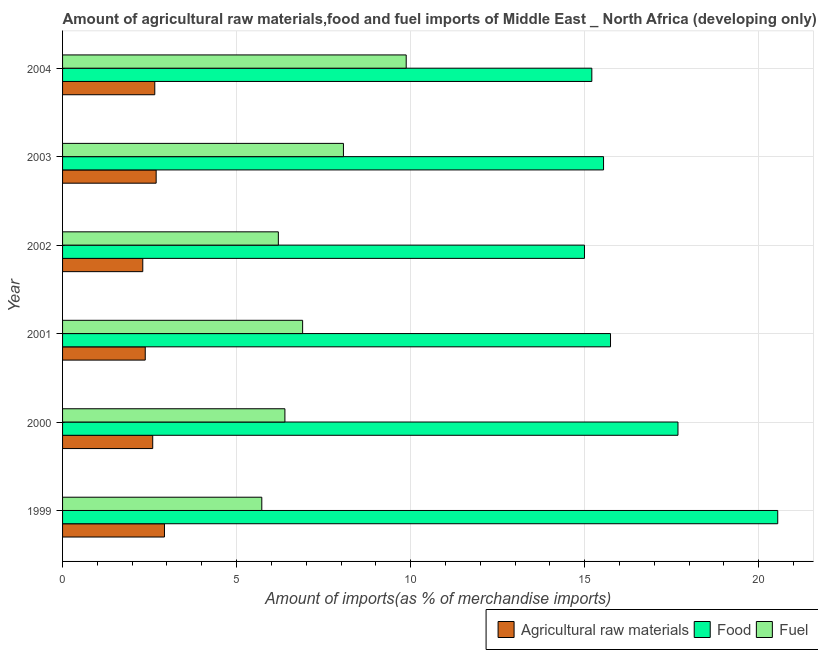How many bars are there on the 5th tick from the top?
Your answer should be very brief. 3. What is the label of the 4th group of bars from the top?
Provide a succinct answer. 2001. What is the percentage of fuel imports in 2000?
Your answer should be compact. 6.39. Across all years, what is the maximum percentage of fuel imports?
Provide a short and direct response. 9.87. Across all years, what is the minimum percentage of fuel imports?
Provide a succinct answer. 5.72. What is the total percentage of raw materials imports in the graph?
Ensure brevity in your answer.  15.54. What is the difference between the percentage of fuel imports in 1999 and that in 2003?
Keep it short and to the point. -2.35. What is the difference between the percentage of food imports in 1999 and the percentage of fuel imports in 2004?
Keep it short and to the point. 10.67. What is the average percentage of food imports per year?
Make the answer very short. 16.62. In the year 2000, what is the difference between the percentage of food imports and percentage of fuel imports?
Your response must be concise. 11.29. What is the difference between the highest and the second highest percentage of fuel imports?
Ensure brevity in your answer.  1.8. What is the difference between the highest and the lowest percentage of fuel imports?
Your answer should be very brief. 4.15. In how many years, is the percentage of raw materials imports greater than the average percentage of raw materials imports taken over all years?
Make the answer very short. 4. What does the 1st bar from the top in 2004 represents?
Make the answer very short. Fuel. What does the 1st bar from the bottom in 1999 represents?
Ensure brevity in your answer.  Agricultural raw materials. Is it the case that in every year, the sum of the percentage of raw materials imports and percentage of food imports is greater than the percentage of fuel imports?
Make the answer very short. Yes. How many bars are there?
Offer a very short reply. 18. Are all the bars in the graph horizontal?
Your answer should be compact. Yes. How many years are there in the graph?
Keep it short and to the point. 6. What is the difference between two consecutive major ticks on the X-axis?
Make the answer very short. 5. Does the graph contain grids?
Your answer should be compact. Yes. What is the title of the graph?
Offer a terse response. Amount of agricultural raw materials,food and fuel imports of Middle East _ North Africa (developing only). What is the label or title of the X-axis?
Make the answer very short. Amount of imports(as % of merchandise imports). What is the label or title of the Y-axis?
Your answer should be compact. Year. What is the Amount of imports(as % of merchandise imports) of Agricultural raw materials in 1999?
Your answer should be very brief. 2.93. What is the Amount of imports(as % of merchandise imports) in Food in 1999?
Provide a succinct answer. 20.55. What is the Amount of imports(as % of merchandise imports) of Fuel in 1999?
Your answer should be very brief. 5.72. What is the Amount of imports(as % of merchandise imports) of Agricultural raw materials in 2000?
Ensure brevity in your answer.  2.59. What is the Amount of imports(as % of merchandise imports) in Food in 2000?
Offer a terse response. 17.68. What is the Amount of imports(as % of merchandise imports) of Fuel in 2000?
Offer a terse response. 6.39. What is the Amount of imports(as % of merchandise imports) in Agricultural raw materials in 2001?
Offer a terse response. 2.38. What is the Amount of imports(as % of merchandise imports) in Food in 2001?
Make the answer very short. 15.74. What is the Amount of imports(as % of merchandise imports) in Fuel in 2001?
Offer a terse response. 6.9. What is the Amount of imports(as % of merchandise imports) of Agricultural raw materials in 2002?
Give a very brief answer. 2.3. What is the Amount of imports(as % of merchandise imports) of Food in 2002?
Give a very brief answer. 14.99. What is the Amount of imports(as % of merchandise imports) in Fuel in 2002?
Your answer should be compact. 6.2. What is the Amount of imports(as % of merchandise imports) in Agricultural raw materials in 2003?
Keep it short and to the point. 2.69. What is the Amount of imports(as % of merchandise imports) of Food in 2003?
Give a very brief answer. 15.54. What is the Amount of imports(as % of merchandise imports) of Fuel in 2003?
Make the answer very short. 8.07. What is the Amount of imports(as % of merchandise imports) in Agricultural raw materials in 2004?
Keep it short and to the point. 2.65. What is the Amount of imports(as % of merchandise imports) of Food in 2004?
Your answer should be very brief. 15.2. What is the Amount of imports(as % of merchandise imports) in Fuel in 2004?
Ensure brevity in your answer.  9.87. Across all years, what is the maximum Amount of imports(as % of merchandise imports) in Agricultural raw materials?
Your response must be concise. 2.93. Across all years, what is the maximum Amount of imports(as % of merchandise imports) of Food?
Give a very brief answer. 20.55. Across all years, what is the maximum Amount of imports(as % of merchandise imports) of Fuel?
Your answer should be very brief. 9.87. Across all years, what is the minimum Amount of imports(as % of merchandise imports) of Agricultural raw materials?
Provide a short and direct response. 2.3. Across all years, what is the minimum Amount of imports(as % of merchandise imports) in Food?
Provide a succinct answer. 14.99. Across all years, what is the minimum Amount of imports(as % of merchandise imports) of Fuel?
Give a very brief answer. 5.72. What is the total Amount of imports(as % of merchandise imports) in Agricultural raw materials in the graph?
Provide a short and direct response. 15.54. What is the total Amount of imports(as % of merchandise imports) in Food in the graph?
Your response must be concise. 99.71. What is the total Amount of imports(as % of merchandise imports) in Fuel in the graph?
Make the answer very short. 43.15. What is the difference between the Amount of imports(as % of merchandise imports) in Agricultural raw materials in 1999 and that in 2000?
Your answer should be compact. 0.34. What is the difference between the Amount of imports(as % of merchandise imports) in Food in 1999 and that in 2000?
Your answer should be compact. 2.87. What is the difference between the Amount of imports(as % of merchandise imports) in Fuel in 1999 and that in 2000?
Your response must be concise. -0.66. What is the difference between the Amount of imports(as % of merchandise imports) of Agricultural raw materials in 1999 and that in 2001?
Your answer should be compact. 0.55. What is the difference between the Amount of imports(as % of merchandise imports) in Food in 1999 and that in 2001?
Make the answer very short. 4.8. What is the difference between the Amount of imports(as % of merchandise imports) in Fuel in 1999 and that in 2001?
Give a very brief answer. -1.17. What is the difference between the Amount of imports(as % of merchandise imports) of Agricultural raw materials in 1999 and that in 2002?
Provide a succinct answer. 0.62. What is the difference between the Amount of imports(as % of merchandise imports) of Food in 1999 and that in 2002?
Make the answer very short. 5.55. What is the difference between the Amount of imports(as % of merchandise imports) in Fuel in 1999 and that in 2002?
Provide a succinct answer. -0.48. What is the difference between the Amount of imports(as % of merchandise imports) of Agricultural raw materials in 1999 and that in 2003?
Provide a succinct answer. 0.24. What is the difference between the Amount of imports(as % of merchandise imports) of Food in 1999 and that in 2003?
Your answer should be very brief. 5. What is the difference between the Amount of imports(as % of merchandise imports) in Fuel in 1999 and that in 2003?
Your answer should be compact. -2.35. What is the difference between the Amount of imports(as % of merchandise imports) of Agricultural raw materials in 1999 and that in 2004?
Provide a succinct answer. 0.28. What is the difference between the Amount of imports(as % of merchandise imports) in Food in 1999 and that in 2004?
Your answer should be compact. 5.34. What is the difference between the Amount of imports(as % of merchandise imports) in Fuel in 1999 and that in 2004?
Your response must be concise. -4.15. What is the difference between the Amount of imports(as % of merchandise imports) of Agricultural raw materials in 2000 and that in 2001?
Provide a short and direct response. 0.21. What is the difference between the Amount of imports(as % of merchandise imports) of Food in 2000 and that in 2001?
Ensure brevity in your answer.  1.94. What is the difference between the Amount of imports(as % of merchandise imports) of Fuel in 2000 and that in 2001?
Offer a very short reply. -0.51. What is the difference between the Amount of imports(as % of merchandise imports) of Agricultural raw materials in 2000 and that in 2002?
Offer a terse response. 0.29. What is the difference between the Amount of imports(as % of merchandise imports) in Food in 2000 and that in 2002?
Give a very brief answer. 2.69. What is the difference between the Amount of imports(as % of merchandise imports) of Fuel in 2000 and that in 2002?
Your answer should be compact. 0.19. What is the difference between the Amount of imports(as % of merchandise imports) in Agricultural raw materials in 2000 and that in 2003?
Make the answer very short. -0.1. What is the difference between the Amount of imports(as % of merchandise imports) in Food in 2000 and that in 2003?
Keep it short and to the point. 2.14. What is the difference between the Amount of imports(as % of merchandise imports) of Fuel in 2000 and that in 2003?
Provide a short and direct response. -1.68. What is the difference between the Amount of imports(as % of merchandise imports) of Agricultural raw materials in 2000 and that in 2004?
Provide a short and direct response. -0.06. What is the difference between the Amount of imports(as % of merchandise imports) of Food in 2000 and that in 2004?
Provide a succinct answer. 2.47. What is the difference between the Amount of imports(as % of merchandise imports) of Fuel in 2000 and that in 2004?
Your answer should be very brief. -3.48. What is the difference between the Amount of imports(as % of merchandise imports) of Agricultural raw materials in 2001 and that in 2002?
Provide a short and direct response. 0.07. What is the difference between the Amount of imports(as % of merchandise imports) in Food in 2001 and that in 2002?
Give a very brief answer. 0.75. What is the difference between the Amount of imports(as % of merchandise imports) in Fuel in 2001 and that in 2002?
Ensure brevity in your answer.  0.7. What is the difference between the Amount of imports(as % of merchandise imports) of Agricultural raw materials in 2001 and that in 2003?
Ensure brevity in your answer.  -0.31. What is the difference between the Amount of imports(as % of merchandise imports) of Food in 2001 and that in 2003?
Offer a terse response. 0.2. What is the difference between the Amount of imports(as % of merchandise imports) in Fuel in 2001 and that in 2003?
Make the answer very short. -1.17. What is the difference between the Amount of imports(as % of merchandise imports) in Agricultural raw materials in 2001 and that in 2004?
Offer a very short reply. -0.27. What is the difference between the Amount of imports(as % of merchandise imports) in Food in 2001 and that in 2004?
Provide a short and direct response. 0.54. What is the difference between the Amount of imports(as % of merchandise imports) in Fuel in 2001 and that in 2004?
Keep it short and to the point. -2.98. What is the difference between the Amount of imports(as % of merchandise imports) of Agricultural raw materials in 2002 and that in 2003?
Your answer should be compact. -0.38. What is the difference between the Amount of imports(as % of merchandise imports) of Food in 2002 and that in 2003?
Keep it short and to the point. -0.55. What is the difference between the Amount of imports(as % of merchandise imports) of Fuel in 2002 and that in 2003?
Provide a short and direct response. -1.87. What is the difference between the Amount of imports(as % of merchandise imports) of Agricultural raw materials in 2002 and that in 2004?
Offer a terse response. -0.34. What is the difference between the Amount of imports(as % of merchandise imports) in Food in 2002 and that in 2004?
Make the answer very short. -0.21. What is the difference between the Amount of imports(as % of merchandise imports) in Fuel in 2002 and that in 2004?
Your answer should be compact. -3.67. What is the difference between the Amount of imports(as % of merchandise imports) in Agricultural raw materials in 2003 and that in 2004?
Offer a terse response. 0.04. What is the difference between the Amount of imports(as % of merchandise imports) in Food in 2003 and that in 2004?
Give a very brief answer. 0.34. What is the difference between the Amount of imports(as % of merchandise imports) of Fuel in 2003 and that in 2004?
Provide a succinct answer. -1.8. What is the difference between the Amount of imports(as % of merchandise imports) of Agricultural raw materials in 1999 and the Amount of imports(as % of merchandise imports) of Food in 2000?
Provide a short and direct response. -14.75. What is the difference between the Amount of imports(as % of merchandise imports) in Agricultural raw materials in 1999 and the Amount of imports(as % of merchandise imports) in Fuel in 2000?
Keep it short and to the point. -3.46. What is the difference between the Amount of imports(as % of merchandise imports) of Food in 1999 and the Amount of imports(as % of merchandise imports) of Fuel in 2000?
Your answer should be compact. 14.16. What is the difference between the Amount of imports(as % of merchandise imports) in Agricultural raw materials in 1999 and the Amount of imports(as % of merchandise imports) in Food in 2001?
Ensure brevity in your answer.  -12.81. What is the difference between the Amount of imports(as % of merchandise imports) of Agricultural raw materials in 1999 and the Amount of imports(as % of merchandise imports) of Fuel in 2001?
Your answer should be compact. -3.97. What is the difference between the Amount of imports(as % of merchandise imports) of Food in 1999 and the Amount of imports(as % of merchandise imports) of Fuel in 2001?
Give a very brief answer. 13.65. What is the difference between the Amount of imports(as % of merchandise imports) in Agricultural raw materials in 1999 and the Amount of imports(as % of merchandise imports) in Food in 2002?
Offer a very short reply. -12.07. What is the difference between the Amount of imports(as % of merchandise imports) of Agricultural raw materials in 1999 and the Amount of imports(as % of merchandise imports) of Fuel in 2002?
Give a very brief answer. -3.27. What is the difference between the Amount of imports(as % of merchandise imports) of Food in 1999 and the Amount of imports(as % of merchandise imports) of Fuel in 2002?
Provide a succinct answer. 14.35. What is the difference between the Amount of imports(as % of merchandise imports) of Agricultural raw materials in 1999 and the Amount of imports(as % of merchandise imports) of Food in 2003?
Keep it short and to the point. -12.61. What is the difference between the Amount of imports(as % of merchandise imports) of Agricultural raw materials in 1999 and the Amount of imports(as % of merchandise imports) of Fuel in 2003?
Your response must be concise. -5.14. What is the difference between the Amount of imports(as % of merchandise imports) of Food in 1999 and the Amount of imports(as % of merchandise imports) of Fuel in 2003?
Provide a succinct answer. 12.48. What is the difference between the Amount of imports(as % of merchandise imports) in Agricultural raw materials in 1999 and the Amount of imports(as % of merchandise imports) in Food in 2004?
Make the answer very short. -12.28. What is the difference between the Amount of imports(as % of merchandise imports) in Agricultural raw materials in 1999 and the Amount of imports(as % of merchandise imports) in Fuel in 2004?
Keep it short and to the point. -6.94. What is the difference between the Amount of imports(as % of merchandise imports) of Food in 1999 and the Amount of imports(as % of merchandise imports) of Fuel in 2004?
Ensure brevity in your answer.  10.67. What is the difference between the Amount of imports(as % of merchandise imports) in Agricultural raw materials in 2000 and the Amount of imports(as % of merchandise imports) in Food in 2001?
Offer a terse response. -13.15. What is the difference between the Amount of imports(as % of merchandise imports) in Agricultural raw materials in 2000 and the Amount of imports(as % of merchandise imports) in Fuel in 2001?
Provide a short and direct response. -4.31. What is the difference between the Amount of imports(as % of merchandise imports) of Food in 2000 and the Amount of imports(as % of merchandise imports) of Fuel in 2001?
Offer a terse response. 10.78. What is the difference between the Amount of imports(as % of merchandise imports) in Agricultural raw materials in 2000 and the Amount of imports(as % of merchandise imports) in Food in 2002?
Provide a short and direct response. -12.4. What is the difference between the Amount of imports(as % of merchandise imports) in Agricultural raw materials in 2000 and the Amount of imports(as % of merchandise imports) in Fuel in 2002?
Your answer should be very brief. -3.61. What is the difference between the Amount of imports(as % of merchandise imports) in Food in 2000 and the Amount of imports(as % of merchandise imports) in Fuel in 2002?
Ensure brevity in your answer.  11.48. What is the difference between the Amount of imports(as % of merchandise imports) in Agricultural raw materials in 2000 and the Amount of imports(as % of merchandise imports) in Food in 2003?
Ensure brevity in your answer.  -12.95. What is the difference between the Amount of imports(as % of merchandise imports) in Agricultural raw materials in 2000 and the Amount of imports(as % of merchandise imports) in Fuel in 2003?
Give a very brief answer. -5.48. What is the difference between the Amount of imports(as % of merchandise imports) of Food in 2000 and the Amount of imports(as % of merchandise imports) of Fuel in 2003?
Your answer should be compact. 9.61. What is the difference between the Amount of imports(as % of merchandise imports) of Agricultural raw materials in 2000 and the Amount of imports(as % of merchandise imports) of Food in 2004?
Provide a short and direct response. -12.62. What is the difference between the Amount of imports(as % of merchandise imports) in Agricultural raw materials in 2000 and the Amount of imports(as % of merchandise imports) in Fuel in 2004?
Your answer should be compact. -7.28. What is the difference between the Amount of imports(as % of merchandise imports) in Food in 2000 and the Amount of imports(as % of merchandise imports) in Fuel in 2004?
Offer a terse response. 7.81. What is the difference between the Amount of imports(as % of merchandise imports) in Agricultural raw materials in 2001 and the Amount of imports(as % of merchandise imports) in Food in 2002?
Keep it short and to the point. -12.62. What is the difference between the Amount of imports(as % of merchandise imports) in Agricultural raw materials in 2001 and the Amount of imports(as % of merchandise imports) in Fuel in 2002?
Offer a terse response. -3.82. What is the difference between the Amount of imports(as % of merchandise imports) of Food in 2001 and the Amount of imports(as % of merchandise imports) of Fuel in 2002?
Your answer should be very brief. 9.54. What is the difference between the Amount of imports(as % of merchandise imports) in Agricultural raw materials in 2001 and the Amount of imports(as % of merchandise imports) in Food in 2003?
Your answer should be compact. -13.17. What is the difference between the Amount of imports(as % of merchandise imports) in Agricultural raw materials in 2001 and the Amount of imports(as % of merchandise imports) in Fuel in 2003?
Your response must be concise. -5.69. What is the difference between the Amount of imports(as % of merchandise imports) of Food in 2001 and the Amount of imports(as % of merchandise imports) of Fuel in 2003?
Give a very brief answer. 7.67. What is the difference between the Amount of imports(as % of merchandise imports) of Agricultural raw materials in 2001 and the Amount of imports(as % of merchandise imports) of Food in 2004?
Make the answer very short. -12.83. What is the difference between the Amount of imports(as % of merchandise imports) in Agricultural raw materials in 2001 and the Amount of imports(as % of merchandise imports) in Fuel in 2004?
Make the answer very short. -7.5. What is the difference between the Amount of imports(as % of merchandise imports) of Food in 2001 and the Amount of imports(as % of merchandise imports) of Fuel in 2004?
Your answer should be very brief. 5.87. What is the difference between the Amount of imports(as % of merchandise imports) of Agricultural raw materials in 2002 and the Amount of imports(as % of merchandise imports) of Food in 2003?
Make the answer very short. -13.24. What is the difference between the Amount of imports(as % of merchandise imports) of Agricultural raw materials in 2002 and the Amount of imports(as % of merchandise imports) of Fuel in 2003?
Your answer should be very brief. -5.76. What is the difference between the Amount of imports(as % of merchandise imports) in Food in 2002 and the Amount of imports(as % of merchandise imports) in Fuel in 2003?
Ensure brevity in your answer.  6.92. What is the difference between the Amount of imports(as % of merchandise imports) in Agricultural raw materials in 2002 and the Amount of imports(as % of merchandise imports) in Food in 2004?
Your answer should be very brief. -12.9. What is the difference between the Amount of imports(as % of merchandise imports) of Agricultural raw materials in 2002 and the Amount of imports(as % of merchandise imports) of Fuel in 2004?
Keep it short and to the point. -7.57. What is the difference between the Amount of imports(as % of merchandise imports) in Food in 2002 and the Amount of imports(as % of merchandise imports) in Fuel in 2004?
Offer a terse response. 5.12. What is the difference between the Amount of imports(as % of merchandise imports) in Agricultural raw materials in 2003 and the Amount of imports(as % of merchandise imports) in Food in 2004?
Your answer should be compact. -12.52. What is the difference between the Amount of imports(as % of merchandise imports) of Agricultural raw materials in 2003 and the Amount of imports(as % of merchandise imports) of Fuel in 2004?
Provide a short and direct response. -7.18. What is the difference between the Amount of imports(as % of merchandise imports) of Food in 2003 and the Amount of imports(as % of merchandise imports) of Fuel in 2004?
Your answer should be very brief. 5.67. What is the average Amount of imports(as % of merchandise imports) in Agricultural raw materials per year?
Make the answer very short. 2.59. What is the average Amount of imports(as % of merchandise imports) in Food per year?
Provide a succinct answer. 16.62. What is the average Amount of imports(as % of merchandise imports) in Fuel per year?
Make the answer very short. 7.19. In the year 1999, what is the difference between the Amount of imports(as % of merchandise imports) in Agricultural raw materials and Amount of imports(as % of merchandise imports) in Food?
Offer a very short reply. -17.62. In the year 1999, what is the difference between the Amount of imports(as % of merchandise imports) of Agricultural raw materials and Amount of imports(as % of merchandise imports) of Fuel?
Provide a succinct answer. -2.8. In the year 1999, what is the difference between the Amount of imports(as % of merchandise imports) in Food and Amount of imports(as % of merchandise imports) in Fuel?
Give a very brief answer. 14.82. In the year 2000, what is the difference between the Amount of imports(as % of merchandise imports) in Agricultural raw materials and Amount of imports(as % of merchandise imports) in Food?
Give a very brief answer. -15.09. In the year 2000, what is the difference between the Amount of imports(as % of merchandise imports) of Agricultural raw materials and Amount of imports(as % of merchandise imports) of Fuel?
Provide a short and direct response. -3.8. In the year 2000, what is the difference between the Amount of imports(as % of merchandise imports) in Food and Amount of imports(as % of merchandise imports) in Fuel?
Your response must be concise. 11.29. In the year 2001, what is the difference between the Amount of imports(as % of merchandise imports) of Agricultural raw materials and Amount of imports(as % of merchandise imports) of Food?
Make the answer very short. -13.37. In the year 2001, what is the difference between the Amount of imports(as % of merchandise imports) in Agricultural raw materials and Amount of imports(as % of merchandise imports) in Fuel?
Ensure brevity in your answer.  -4.52. In the year 2001, what is the difference between the Amount of imports(as % of merchandise imports) in Food and Amount of imports(as % of merchandise imports) in Fuel?
Keep it short and to the point. 8.85. In the year 2002, what is the difference between the Amount of imports(as % of merchandise imports) in Agricultural raw materials and Amount of imports(as % of merchandise imports) in Food?
Offer a terse response. -12.69. In the year 2002, what is the difference between the Amount of imports(as % of merchandise imports) of Agricultural raw materials and Amount of imports(as % of merchandise imports) of Fuel?
Offer a terse response. -3.89. In the year 2002, what is the difference between the Amount of imports(as % of merchandise imports) of Food and Amount of imports(as % of merchandise imports) of Fuel?
Offer a very short reply. 8.79. In the year 2003, what is the difference between the Amount of imports(as % of merchandise imports) of Agricultural raw materials and Amount of imports(as % of merchandise imports) of Food?
Your response must be concise. -12.85. In the year 2003, what is the difference between the Amount of imports(as % of merchandise imports) of Agricultural raw materials and Amount of imports(as % of merchandise imports) of Fuel?
Your answer should be very brief. -5.38. In the year 2003, what is the difference between the Amount of imports(as % of merchandise imports) of Food and Amount of imports(as % of merchandise imports) of Fuel?
Ensure brevity in your answer.  7.47. In the year 2004, what is the difference between the Amount of imports(as % of merchandise imports) of Agricultural raw materials and Amount of imports(as % of merchandise imports) of Food?
Your answer should be compact. -12.56. In the year 2004, what is the difference between the Amount of imports(as % of merchandise imports) of Agricultural raw materials and Amount of imports(as % of merchandise imports) of Fuel?
Make the answer very short. -7.22. In the year 2004, what is the difference between the Amount of imports(as % of merchandise imports) of Food and Amount of imports(as % of merchandise imports) of Fuel?
Your answer should be compact. 5.33. What is the ratio of the Amount of imports(as % of merchandise imports) of Agricultural raw materials in 1999 to that in 2000?
Provide a succinct answer. 1.13. What is the ratio of the Amount of imports(as % of merchandise imports) of Food in 1999 to that in 2000?
Ensure brevity in your answer.  1.16. What is the ratio of the Amount of imports(as % of merchandise imports) of Fuel in 1999 to that in 2000?
Give a very brief answer. 0.9. What is the ratio of the Amount of imports(as % of merchandise imports) of Agricultural raw materials in 1999 to that in 2001?
Ensure brevity in your answer.  1.23. What is the ratio of the Amount of imports(as % of merchandise imports) in Food in 1999 to that in 2001?
Provide a short and direct response. 1.31. What is the ratio of the Amount of imports(as % of merchandise imports) in Fuel in 1999 to that in 2001?
Make the answer very short. 0.83. What is the ratio of the Amount of imports(as % of merchandise imports) in Agricultural raw materials in 1999 to that in 2002?
Your answer should be compact. 1.27. What is the ratio of the Amount of imports(as % of merchandise imports) of Food in 1999 to that in 2002?
Provide a short and direct response. 1.37. What is the ratio of the Amount of imports(as % of merchandise imports) of Fuel in 1999 to that in 2002?
Give a very brief answer. 0.92. What is the ratio of the Amount of imports(as % of merchandise imports) in Agricultural raw materials in 1999 to that in 2003?
Provide a short and direct response. 1.09. What is the ratio of the Amount of imports(as % of merchandise imports) in Food in 1999 to that in 2003?
Your response must be concise. 1.32. What is the ratio of the Amount of imports(as % of merchandise imports) of Fuel in 1999 to that in 2003?
Offer a very short reply. 0.71. What is the ratio of the Amount of imports(as % of merchandise imports) of Agricultural raw materials in 1999 to that in 2004?
Ensure brevity in your answer.  1.1. What is the ratio of the Amount of imports(as % of merchandise imports) in Food in 1999 to that in 2004?
Your answer should be compact. 1.35. What is the ratio of the Amount of imports(as % of merchandise imports) in Fuel in 1999 to that in 2004?
Ensure brevity in your answer.  0.58. What is the ratio of the Amount of imports(as % of merchandise imports) of Agricultural raw materials in 2000 to that in 2001?
Give a very brief answer. 1.09. What is the ratio of the Amount of imports(as % of merchandise imports) of Food in 2000 to that in 2001?
Your answer should be very brief. 1.12. What is the ratio of the Amount of imports(as % of merchandise imports) in Fuel in 2000 to that in 2001?
Provide a short and direct response. 0.93. What is the ratio of the Amount of imports(as % of merchandise imports) of Agricultural raw materials in 2000 to that in 2002?
Provide a short and direct response. 1.12. What is the ratio of the Amount of imports(as % of merchandise imports) in Food in 2000 to that in 2002?
Provide a short and direct response. 1.18. What is the ratio of the Amount of imports(as % of merchandise imports) of Fuel in 2000 to that in 2002?
Ensure brevity in your answer.  1.03. What is the ratio of the Amount of imports(as % of merchandise imports) in Agricultural raw materials in 2000 to that in 2003?
Provide a succinct answer. 0.96. What is the ratio of the Amount of imports(as % of merchandise imports) in Food in 2000 to that in 2003?
Make the answer very short. 1.14. What is the ratio of the Amount of imports(as % of merchandise imports) in Fuel in 2000 to that in 2003?
Give a very brief answer. 0.79. What is the ratio of the Amount of imports(as % of merchandise imports) in Agricultural raw materials in 2000 to that in 2004?
Your answer should be very brief. 0.98. What is the ratio of the Amount of imports(as % of merchandise imports) in Food in 2000 to that in 2004?
Your answer should be compact. 1.16. What is the ratio of the Amount of imports(as % of merchandise imports) of Fuel in 2000 to that in 2004?
Your answer should be compact. 0.65. What is the ratio of the Amount of imports(as % of merchandise imports) in Agricultural raw materials in 2001 to that in 2002?
Your answer should be very brief. 1.03. What is the ratio of the Amount of imports(as % of merchandise imports) of Food in 2001 to that in 2002?
Your answer should be very brief. 1.05. What is the ratio of the Amount of imports(as % of merchandise imports) in Fuel in 2001 to that in 2002?
Your response must be concise. 1.11. What is the ratio of the Amount of imports(as % of merchandise imports) in Agricultural raw materials in 2001 to that in 2003?
Ensure brevity in your answer.  0.88. What is the ratio of the Amount of imports(as % of merchandise imports) in Food in 2001 to that in 2003?
Your response must be concise. 1.01. What is the ratio of the Amount of imports(as % of merchandise imports) in Fuel in 2001 to that in 2003?
Your response must be concise. 0.85. What is the ratio of the Amount of imports(as % of merchandise imports) in Agricultural raw materials in 2001 to that in 2004?
Your answer should be compact. 0.9. What is the ratio of the Amount of imports(as % of merchandise imports) in Food in 2001 to that in 2004?
Your response must be concise. 1.04. What is the ratio of the Amount of imports(as % of merchandise imports) of Fuel in 2001 to that in 2004?
Offer a terse response. 0.7. What is the ratio of the Amount of imports(as % of merchandise imports) of Agricultural raw materials in 2002 to that in 2003?
Your answer should be compact. 0.86. What is the ratio of the Amount of imports(as % of merchandise imports) in Food in 2002 to that in 2003?
Provide a succinct answer. 0.96. What is the ratio of the Amount of imports(as % of merchandise imports) of Fuel in 2002 to that in 2003?
Your answer should be compact. 0.77. What is the ratio of the Amount of imports(as % of merchandise imports) of Agricultural raw materials in 2002 to that in 2004?
Offer a very short reply. 0.87. What is the ratio of the Amount of imports(as % of merchandise imports) of Food in 2002 to that in 2004?
Offer a very short reply. 0.99. What is the ratio of the Amount of imports(as % of merchandise imports) of Fuel in 2002 to that in 2004?
Provide a succinct answer. 0.63. What is the ratio of the Amount of imports(as % of merchandise imports) of Agricultural raw materials in 2003 to that in 2004?
Ensure brevity in your answer.  1.01. What is the ratio of the Amount of imports(as % of merchandise imports) of Food in 2003 to that in 2004?
Your response must be concise. 1.02. What is the ratio of the Amount of imports(as % of merchandise imports) of Fuel in 2003 to that in 2004?
Your answer should be very brief. 0.82. What is the difference between the highest and the second highest Amount of imports(as % of merchandise imports) in Agricultural raw materials?
Your response must be concise. 0.24. What is the difference between the highest and the second highest Amount of imports(as % of merchandise imports) in Food?
Your answer should be compact. 2.87. What is the difference between the highest and the second highest Amount of imports(as % of merchandise imports) of Fuel?
Make the answer very short. 1.8. What is the difference between the highest and the lowest Amount of imports(as % of merchandise imports) of Agricultural raw materials?
Keep it short and to the point. 0.62. What is the difference between the highest and the lowest Amount of imports(as % of merchandise imports) in Food?
Your answer should be very brief. 5.55. What is the difference between the highest and the lowest Amount of imports(as % of merchandise imports) of Fuel?
Ensure brevity in your answer.  4.15. 